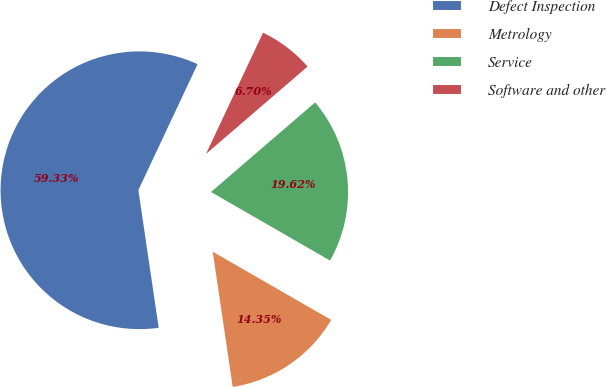Convert chart to OTSL. <chart><loc_0><loc_0><loc_500><loc_500><pie_chart><fcel>Defect Inspection<fcel>Metrology<fcel>Service<fcel>Software and other<nl><fcel>59.33%<fcel>14.35%<fcel>19.62%<fcel>6.7%<nl></chart> 